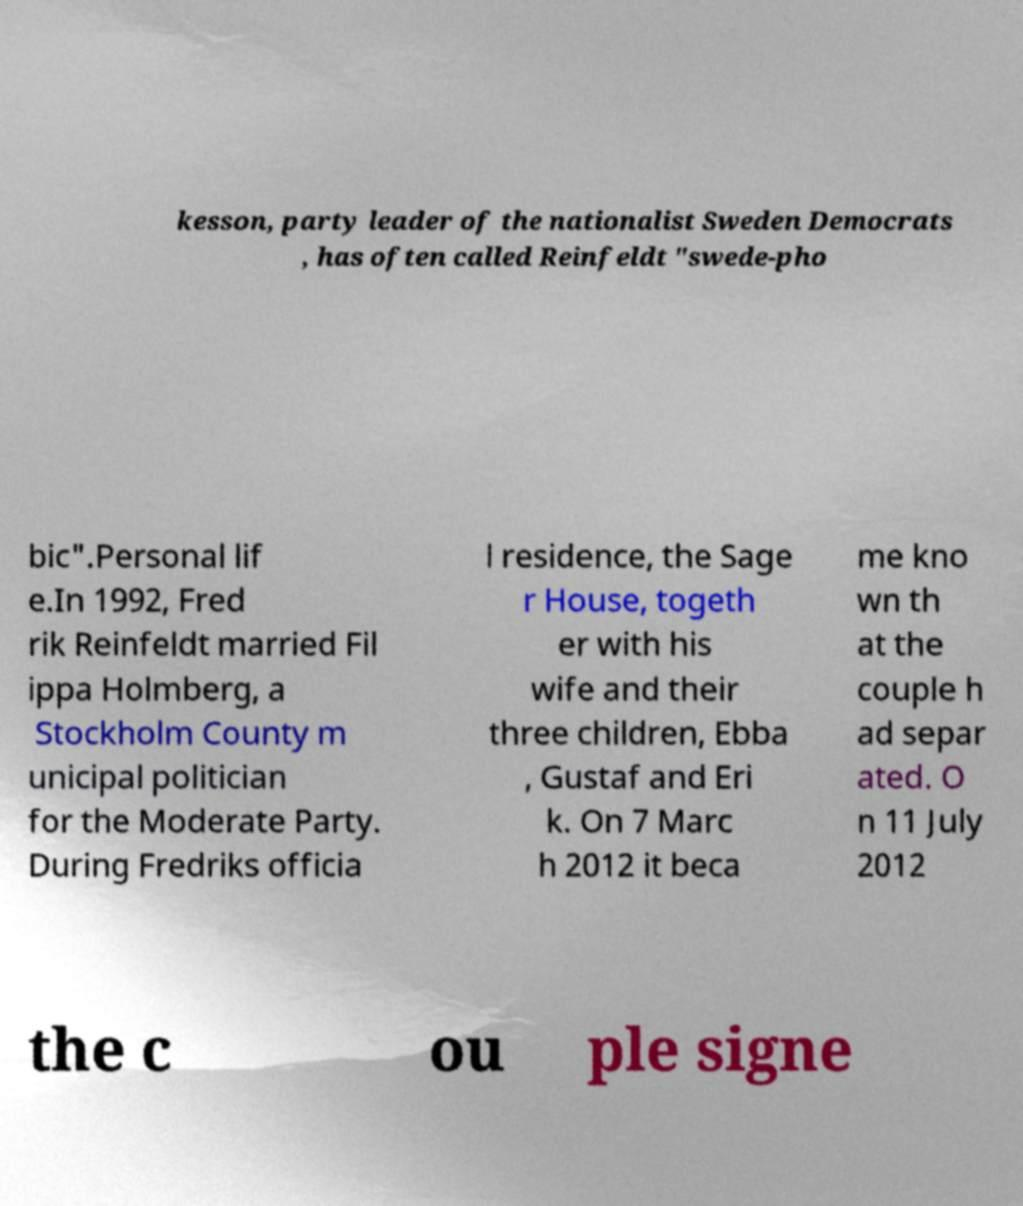I need the written content from this picture converted into text. Can you do that? kesson, party leader of the nationalist Sweden Democrats , has often called Reinfeldt "swede-pho bic".Personal lif e.In 1992, Fred rik Reinfeldt married Fil ippa Holmberg, a Stockholm County m unicipal politician for the Moderate Party. During Fredriks officia l residence, the Sage r House, togeth er with his wife and their three children, Ebba , Gustaf and Eri k. On 7 Marc h 2012 it beca me kno wn th at the couple h ad separ ated. O n 11 July 2012 the c ou ple signe 